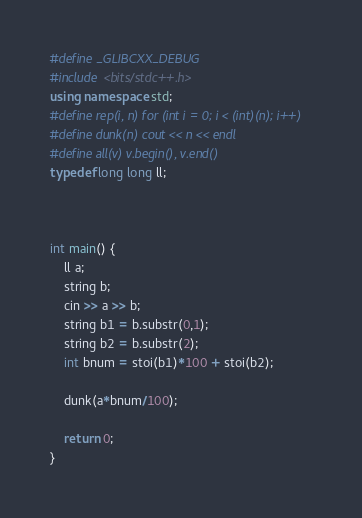<code> <loc_0><loc_0><loc_500><loc_500><_C++_>#define _GLIBCXX_DEBUG
#include <bits/stdc++.h>
using namespace std;
#define rep(i, n) for (int i = 0; i < (int)(n); i++)
#define dunk(n) cout << n << endl
#define all(v) v.begin(), v.end()
typedef long long ll;



int main() {
    ll a;
    string b;
    cin >> a >> b;
    string b1 = b.substr(0,1);
    string b2 = b.substr(2);
    int bnum = stoi(b1)*100 + stoi(b2);
    
    dunk(a*bnum/100);
    
    return 0;
}

</code> 